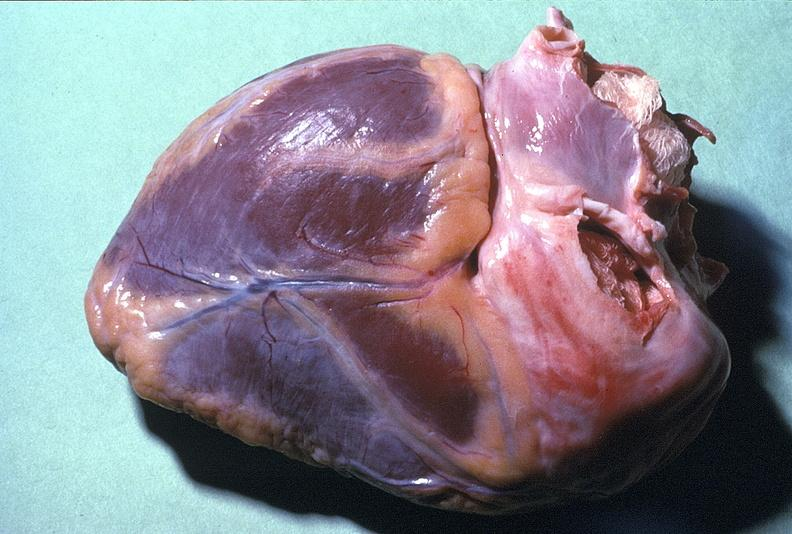s siamese twins present?
Answer the question using a single word or phrase. No 